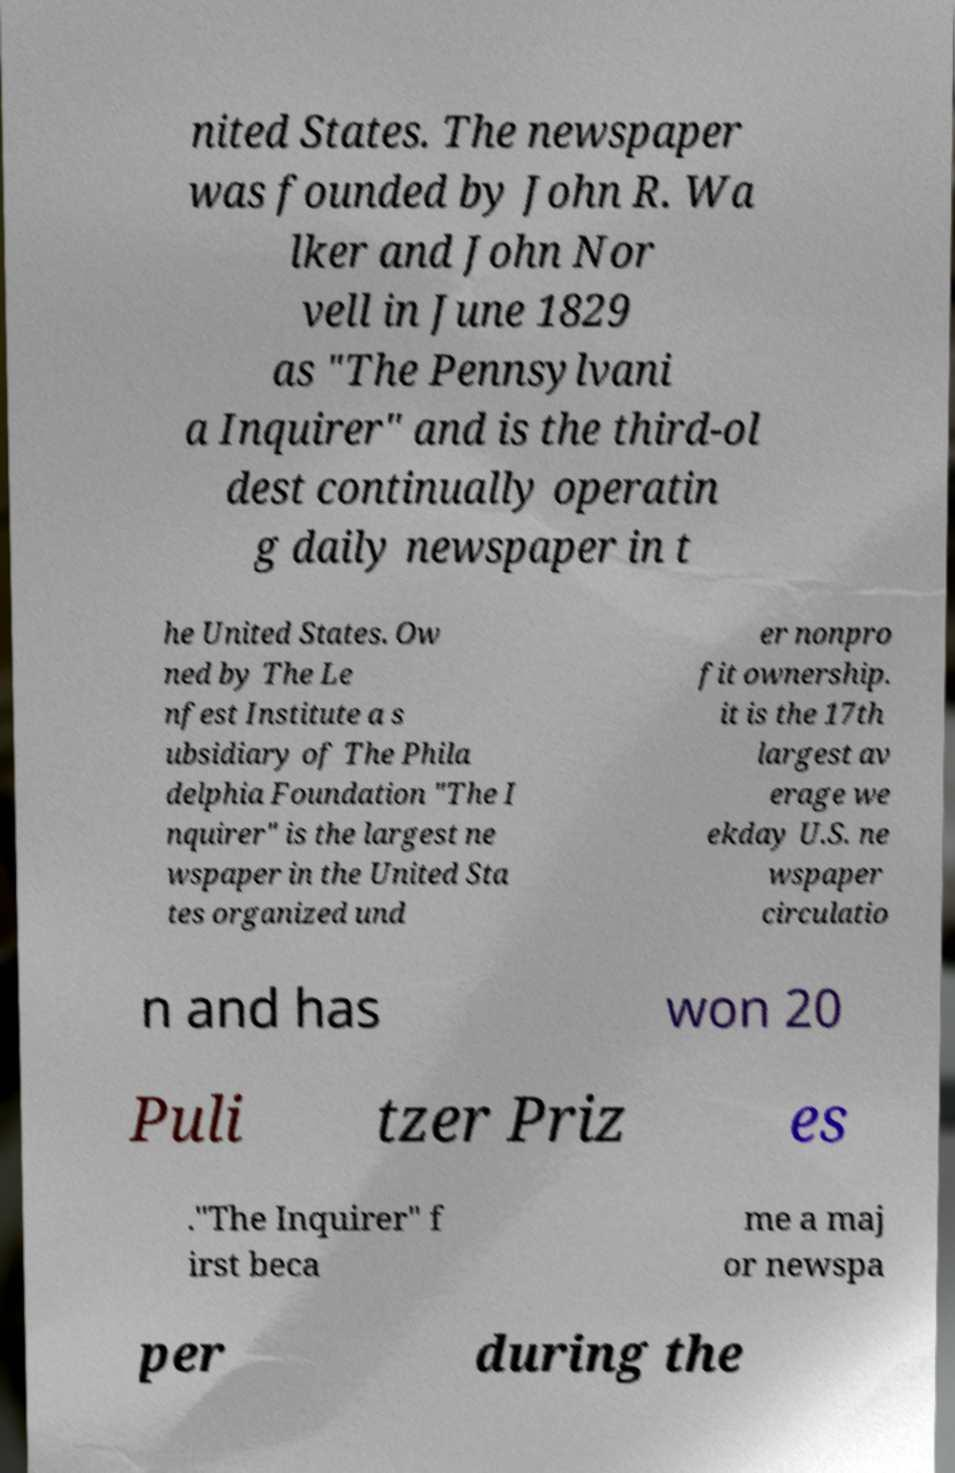For documentation purposes, I need the text within this image transcribed. Could you provide that? nited States. The newspaper was founded by John R. Wa lker and John Nor vell in June 1829 as "The Pennsylvani a Inquirer" and is the third-ol dest continually operatin g daily newspaper in t he United States. Ow ned by The Le nfest Institute a s ubsidiary of The Phila delphia Foundation "The I nquirer" is the largest ne wspaper in the United Sta tes organized und er nonpro fit ownership. it is the 17th largest av erage we ekday U.S. ne wspaper circulatio n and has won 20 Puli tzer Priz es ."The Inquirer" f irst beca me a maj or newspa per during the 